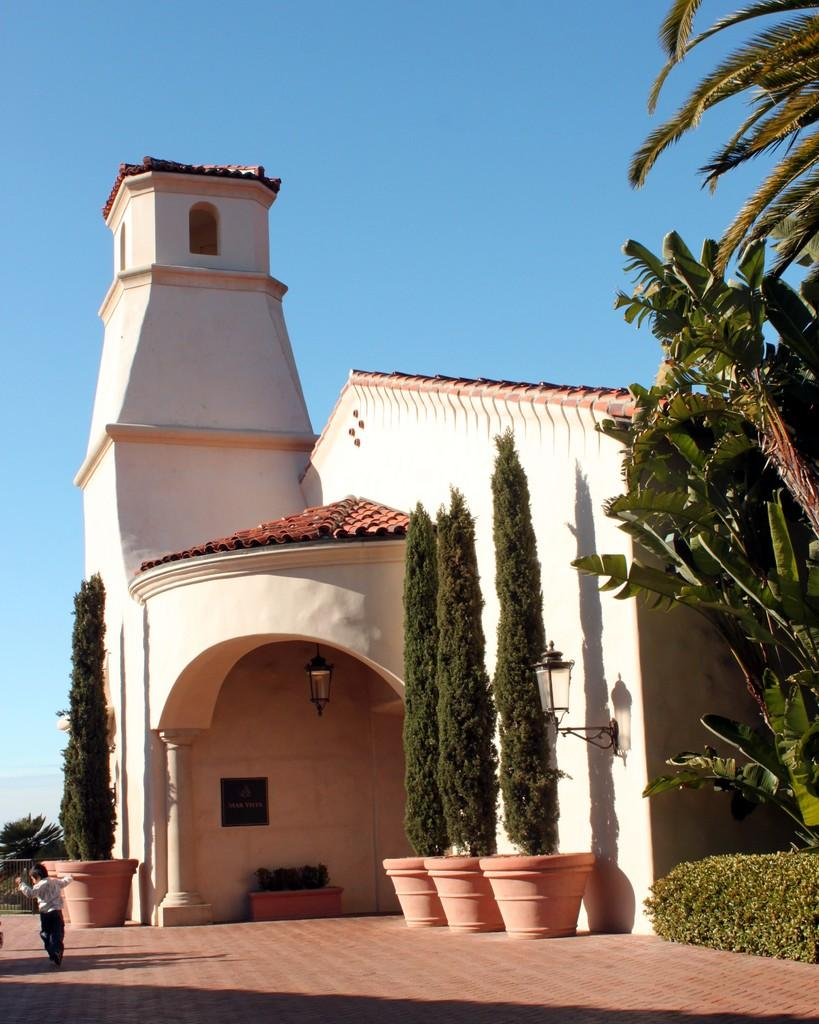What type of structure is visible in the image? There is a house in the image. What other natural elements can be seen in the image? There are trees in the image. What objects are present that might be used for gardening? There are pots and plants in the image. Can you describe the person in the image? There is a person in the image. What type of barrier is present in the image? There is a fence in the image. What type of illumination is present in the image? There are lights in the image. What can be seen in the background of the image? The sky is visible in the background of the image. What is the color of the sky in the image? The sky is blue in color. What color is the egg that the person is holding in the image? There is no egg present in the image. What emotion does the person in the image feel when they are ashamed? The image does not provide information about the person's emotions, including shame. 